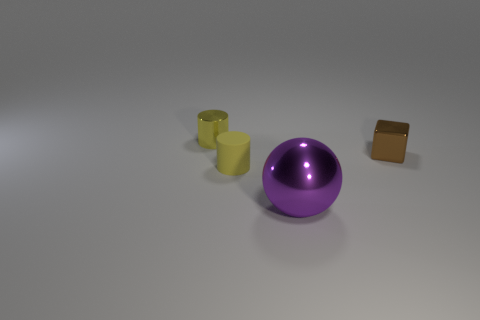Do the yellow metallic thing and the brown metallic thing have the same shape?
Provide a short and direct response. No. How many small metal things are left of the tiny brown metallic object and on the right side of the tiny shiny cylinder?
Provide a short and direct response. 0. How many objects are either brown metal cubes or things behind the purple object?
Offer a very short reply. 3. Are there more yellow rubber cylinders than tiny blue shiny things?
Keep it short and to the point. Yes. There is a metallic thing in front of the cube; what is its shape?
Keep it short and to the point. Sphere. How many other metal things have the same shape as the purple thing?
Offer a terse response. 0. There is a yellow object in front of the small cylinder that is behind the small metal cube; what size is it?
Provide a short and direct response. Small. How many red objects are either small cylinders or spheres?
Make the answer very short. 0. Are there fewer small brown metal cubes that are in front of the small brown cube than tiny blocks to the left of the large object?
Your answer should be compact. No. There is a rubber cylinder; is its size the same as the thing on the right side of the big purple shiny sphere?
Keep it short and to the point. Yes. 